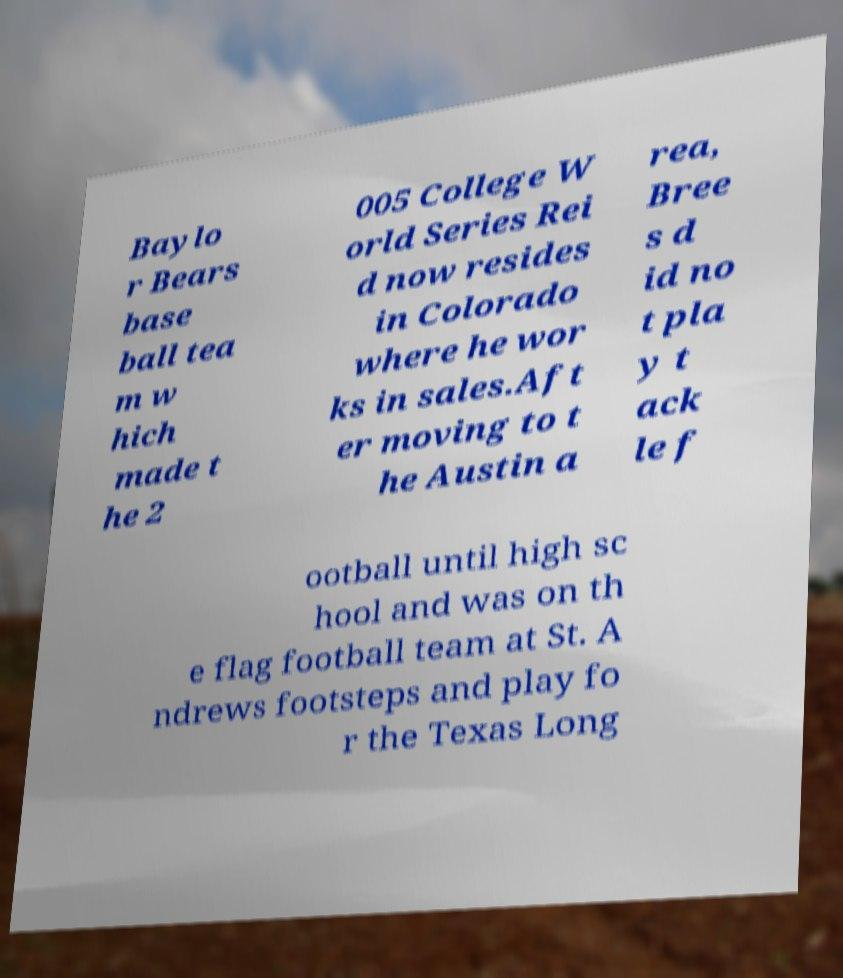Please identify and transcribe the text found in this image. Baylo r Bears base ball tea m w hich made t he 2 005 College W orld Series Rei d now resides in Colorado where he wor ks in sales.Aft er moving to t he Austin a rea, Bree s d id no t pla y t ack le f ootball until high sc hool and was on th e flag football team at St. A ndrews footsteps and play fo r the Texas Long 